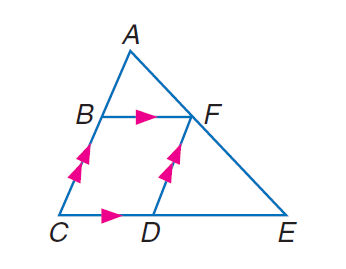Answer the mathemtical geometry problem and directly provide the correct option letter.
Question: Find F E if A B = 6, A F = 8, B C = x, C D = y, D E = 2 y - 3, and F E = x + \frac { 10 } { 3 }.
Choices: A: 9 B: 10 C: \frac { 40 } { 3 } D: 15 C 